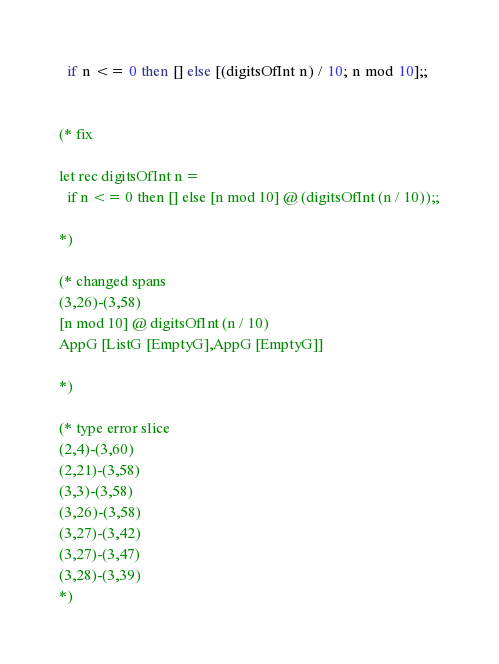<code> <loc_0><loc_0><loc_500><loc_500><_OCaml_>  if n <= 0 then [] else [(digitsOfInt n) / 10; n mod 10];;


(* fix

let rec digitsOfInt n =
  if n <= 0 then [] else [n mod 10] @ (digitsOfInt (n / 10));;

*)

(* changed spans
(3,26)-(3,58)
[n mod 10] @ digitsOfInt (n / 10)
AppG [ListG [EmptyG],AppG [EmptyG]]

*)

(* type error slice
(2,4)-(3,60)
(2,21)-(3,58)
(3,3)-(3,58)
(3,26)-(3,58)
(3,27)-(3,42)
(3,27)-(3,47)
(3,28)-(3,39)
*)
</code> 